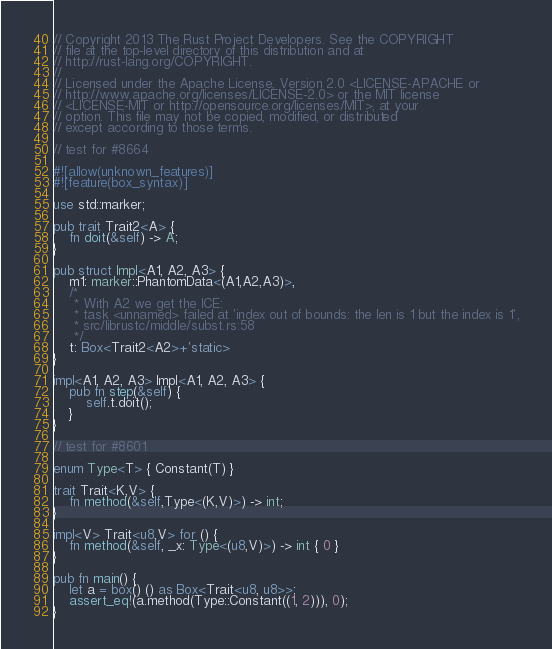<code> <loc_0><loc_0><loc_500><loc_500><_Rust_>// Copyright 2013 The Rust Project Developers. See the COPYRIGHT
// file at the top-level directory of this distribution and at
// http://rust-lang.org/COPYRIGHT.
//
// Licensed under the Apache License, Version 2.0 <LICENSE-APACHE or
// http://www.apache.org/licenses/LICENSE-2.0> or the MIT license
// <LICENSE-MIT or http://opensource.org/licenses/MIT>, at your
// option. This file may not be copied, modified, or distributed
// except according to those terms.

// test for #8664

#![allow(unknown_features)]
#![feature(box_syntax)]

use std::marker;

pub trait Trait2<A> {
    fn doit(&self) -> A;
}

pub struct Impl<A1, A2, A3> {
    m1: marker::PhantomData<(A1,A2,A3)>,
    /*
     * With A2 we get the ICE:
     * task <unnamed> failed at 'index out of bounds: the len is 1 but the index is 1',
     * src/librustc/middle/subst.rs:58
     */
    t: Box<Trait2<A2>+'static>
}

impl<A1, A2, A3> Impl<A1, A2, A3> {
    pub fn step(&self) {
        self.t.doit();
    }
}

// test for #8601

enum Type<T> { Constant(T) }

trait Trait<K,V> {
    fn method(&self,Type<(K,V)>) -> int;
}

impl<V> Trait<u8,V> for () {
    fn method(&self, _x: Type<(u8,V)>) -> int { 0 }
}

pub fn main() {
    let a = box() () as Box<Trait<u8, u8>>;
    assert_eq!(a.method(Type::Constant((1, 2))), 0);
}
</code> 